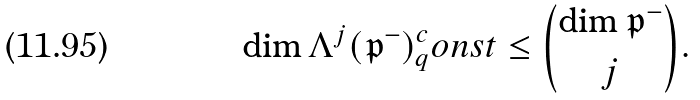Convert formula to latex. <formula><loc_0><loc_0><loc_500><loc_500>\dim \Lambda ^ { j } ( \mathfrak { p } ^ { - } ) _ { q } ^ { c } o n s t \leq \binom { \dim \mathfrak { p } ^ { - } } { j } .</formula> 